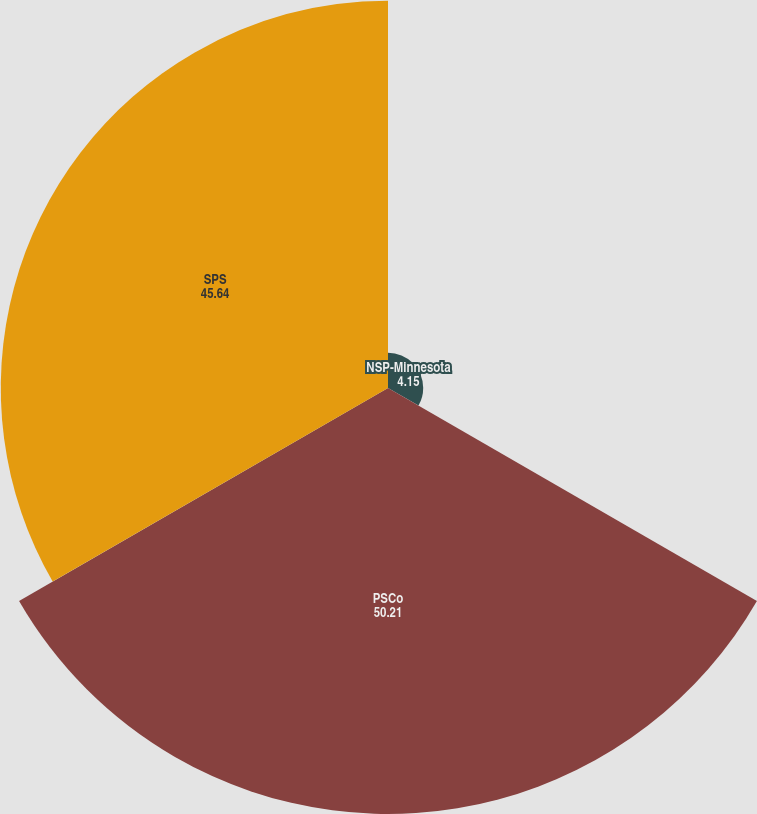Convert chart. <chart><loc_0><loc_0><loc_500><loc_500><pie_chart><fcel>NSP-Minnesota<fcel>PSCo<fcel>SPS<nl><fcel>4.15%<fcel>50.21%<fcel>45.64%<nl></chart> 